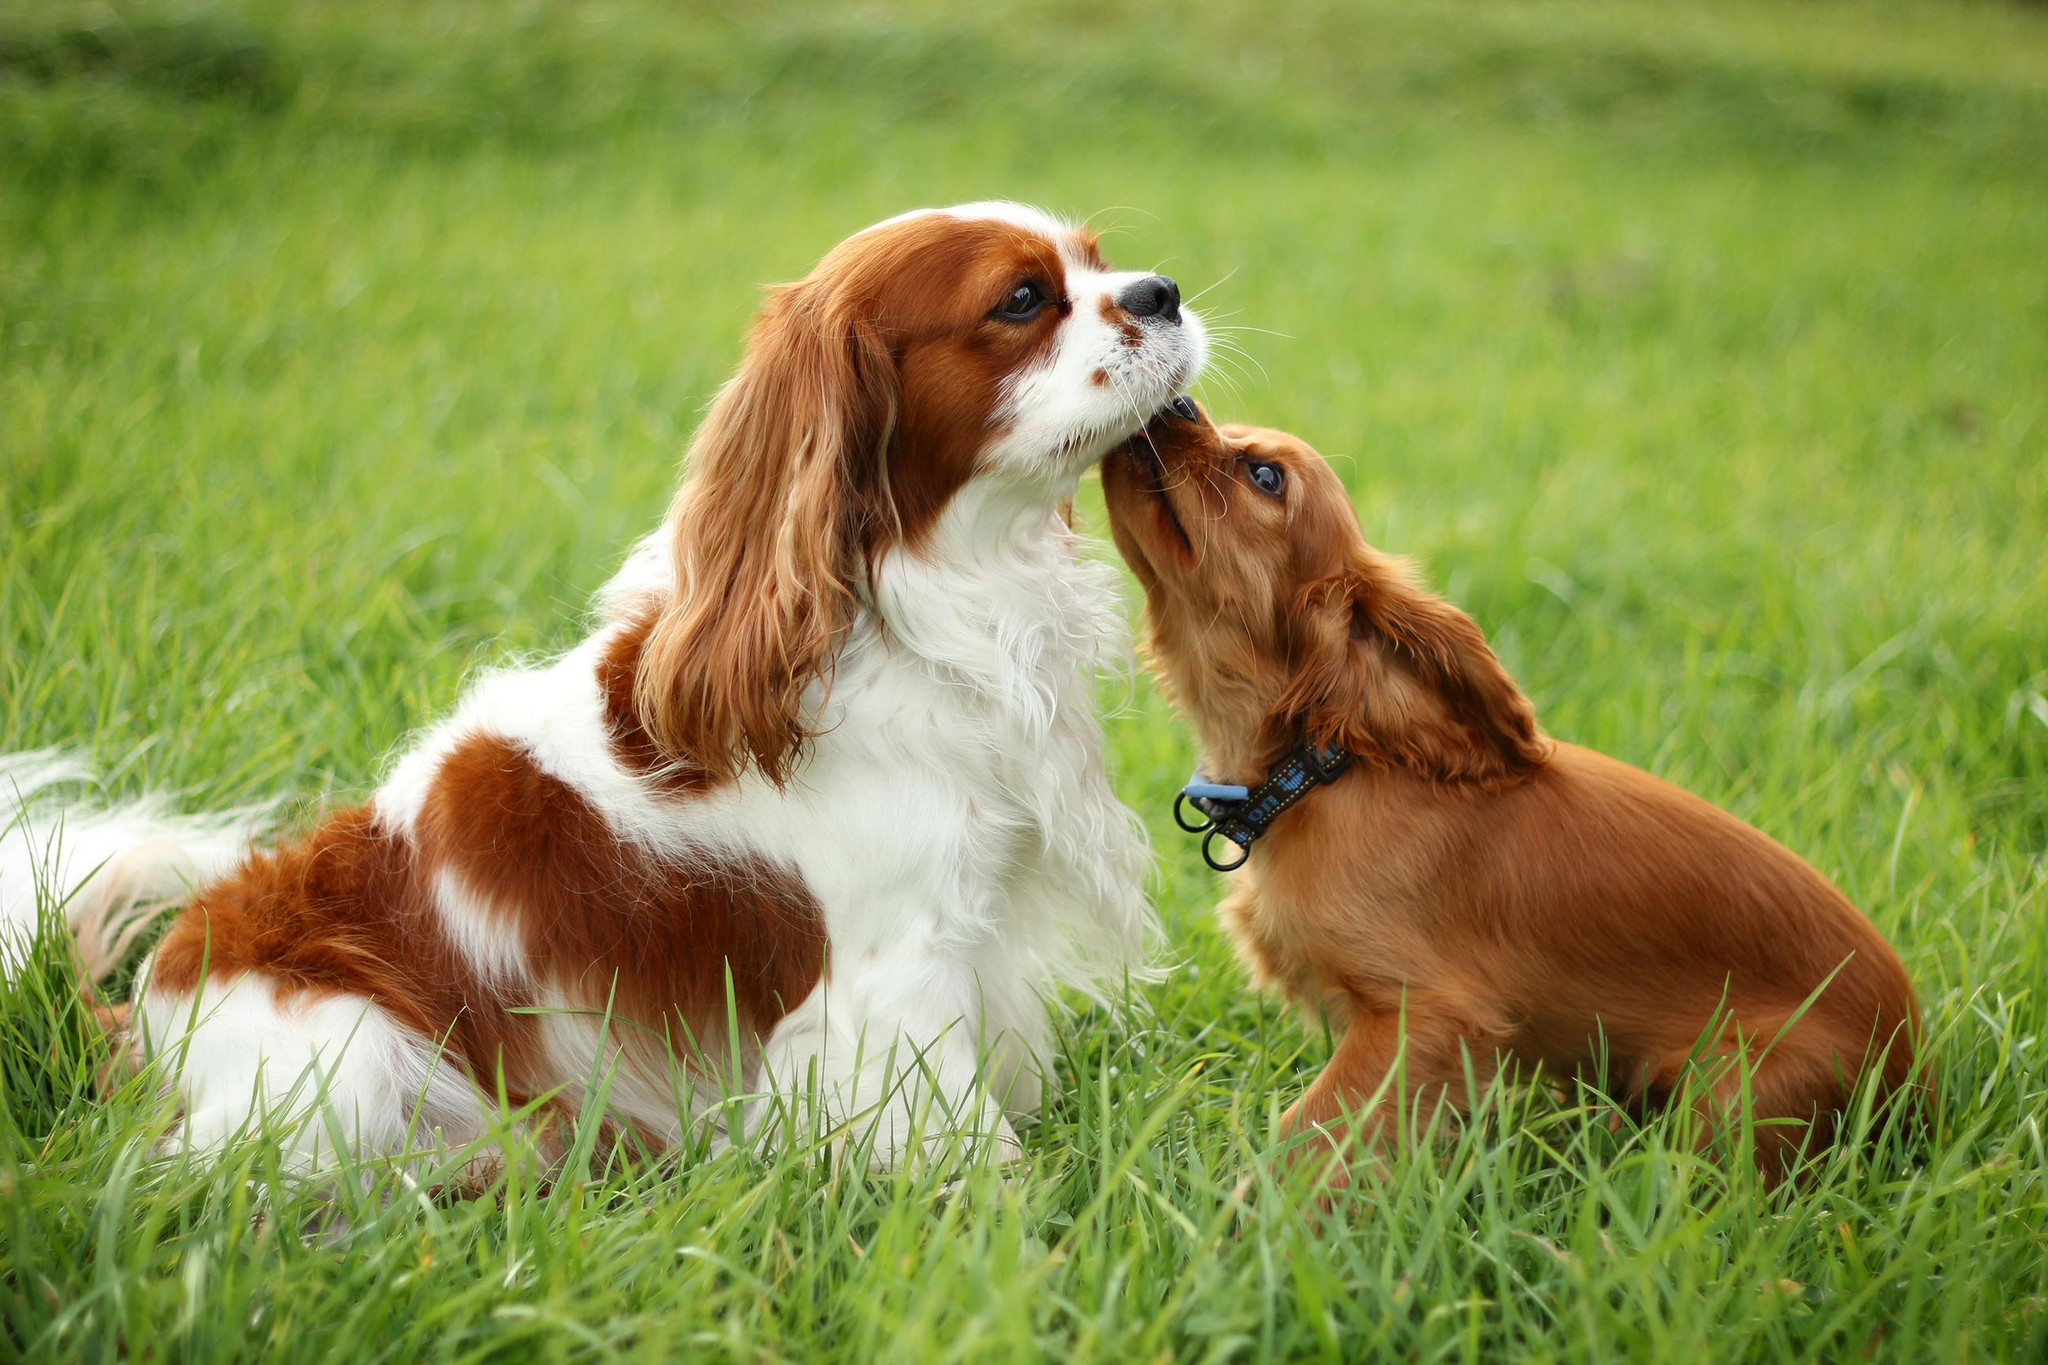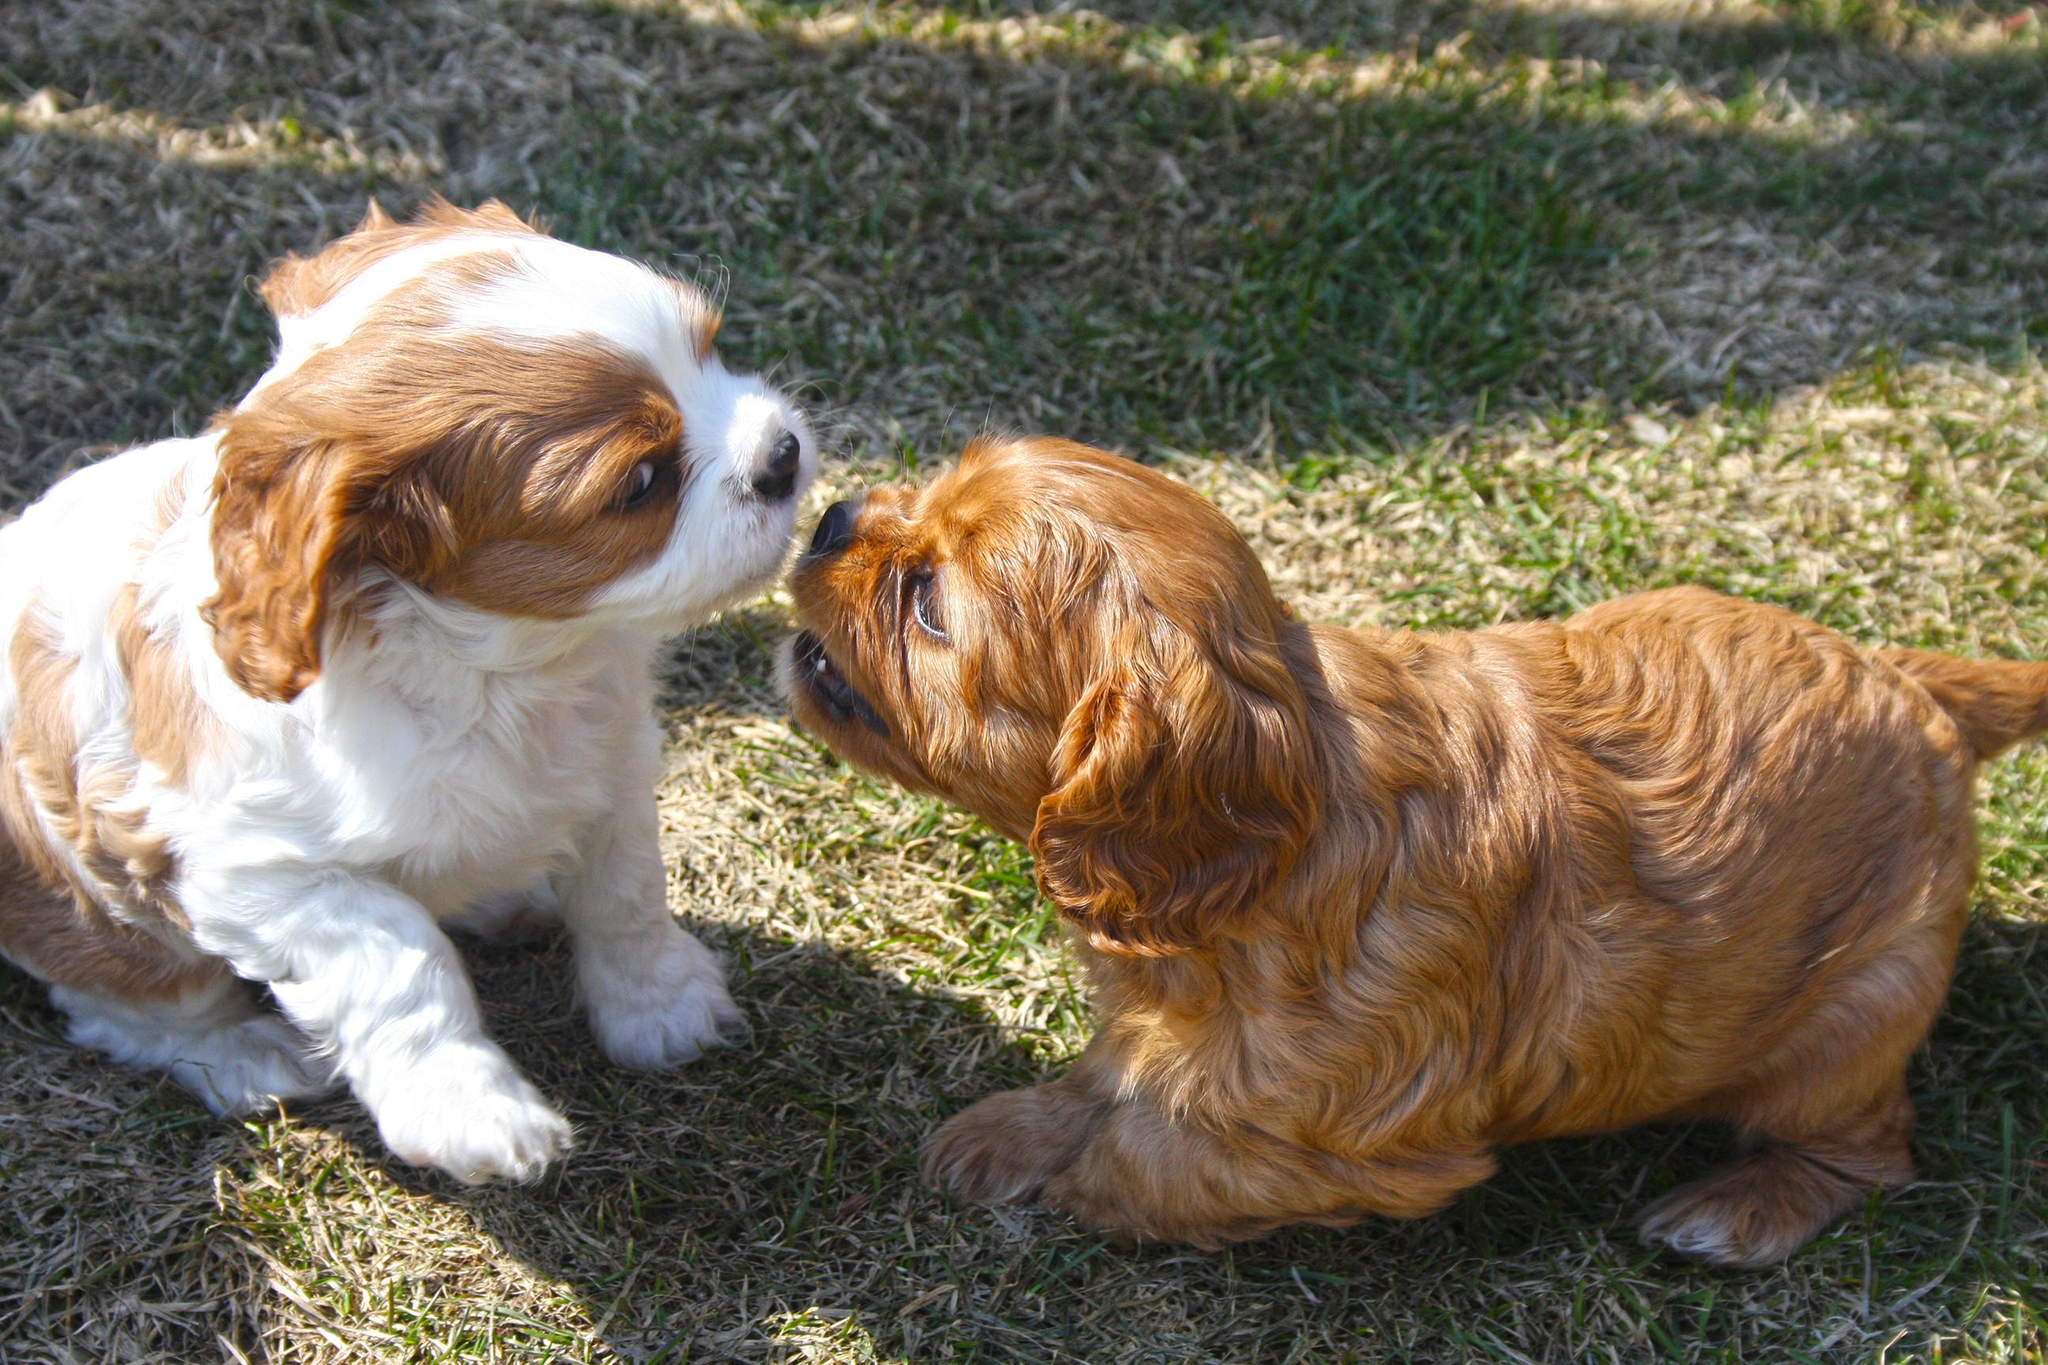The first image is the image on the left, the second image is the image on the right. Examine the images to the left and right. Is the description "One image has a human body part as well as dogs." accurate? Answer yes or no. No. The first image is the image on the left, the second image is the image on the right. Considering the images on both sides, is "Two puppies are being held by human hands." valid? Answer yes or no. No. 